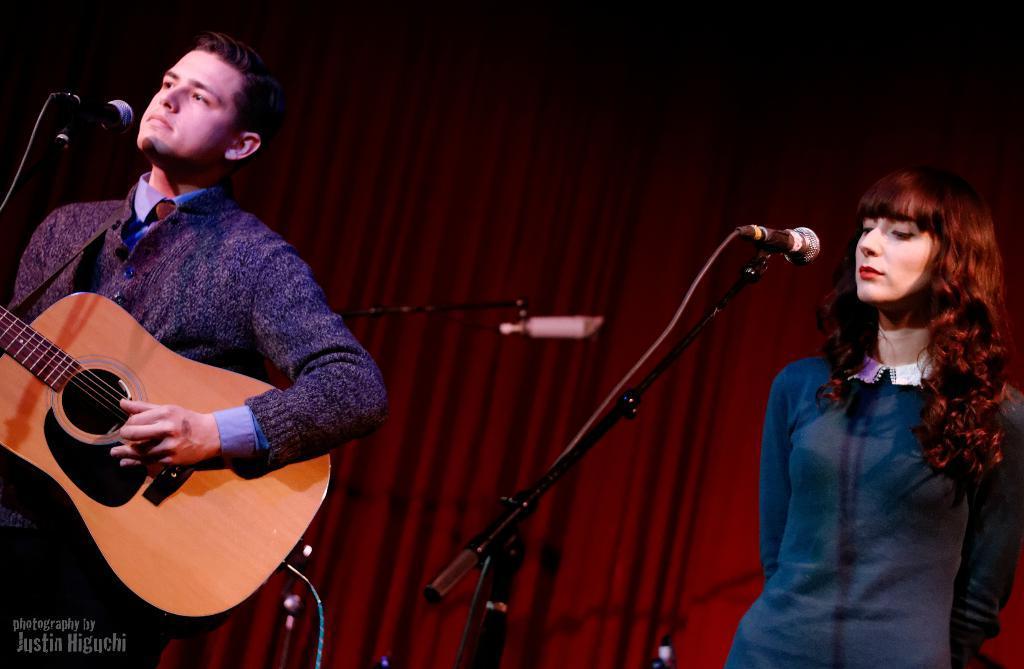How would you summarize this image in a sentence or two? In this picture, we see man and woman standing over there. The woman in the right corner wearing blue t-shirt is looking at the microphone, she might be singing and the man on the left corner is playing guitar and he is also and he is also he might be singing on microphone. Behind them, we see a red color curtain, curtain. 